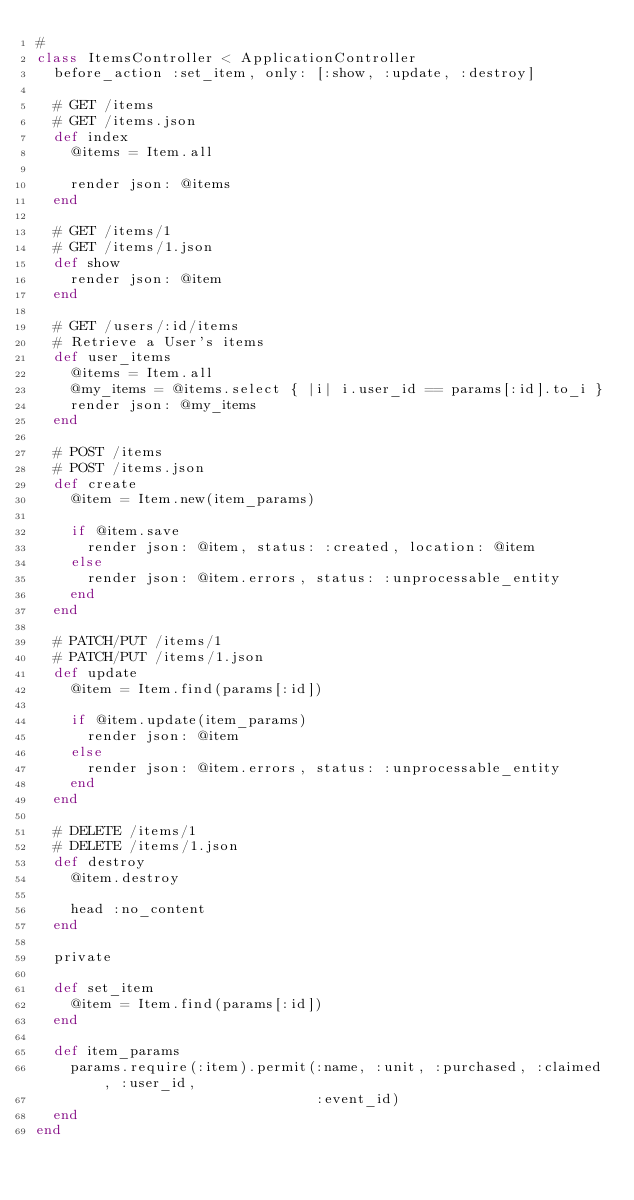<code> <loc_0><loc_0><loc_500><loc_500><_Ruby_>#
class ItemsController < ApplicationController
  before_action :set_item, only: [:show, :update, :destroy]

  # GET /items
  # GET /items.json
  def index
    @items = Item.all

    render json: @items
  end

  # GET /items/1
  # GET /items/1.json
  def show
    render json: @item
  end

  # GET /users/:id/items
  # Retrieve a User's items
  def user_items
    @items = Item.all
    @my_items = @items.select { |i| i.user_id == params[:id].to_i }
    render json: @my_items
  end

  # POST /items
  # POST /items.json
  def create
    @item = Item.new(item_params)

    if @item.save
      render json: @item, status: :created, location: @item
    else
      render json: @item.errors, status: :unprocessable_entity
    end
  end

  # PATCH/PUT /items/1
  # PATCH/PUT /items/1.json
  def update
    @item = Item.find(params[:id])

    if @item.update(item_params)
      render json: @item
    else
      render json: @item.errors, status: :unprocessable_entity
    end
  end

  # DELETE /items/1
  # DELETE /items/1.json
  def destroy
    @item.destroy

    head :no_content
  end

  private

  def set_item
    @item = Item.find(params[:id])
  end

  def item_params
    params.require(:item).permit(:name, :unit, :purchased, :claimed, :user_id,
                                 :event_id)
  end
end
</code> 